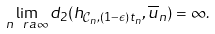<formula> <loc_0><loc_0><loc_500><loc_500>\lim _ { n \ r a \infty } d _ { 2 } ( h _ { \mathcal { C } _ { n } , ( 1 - \epsilon ) t _ { n } } , \overline { u } _ { n } ) = \infty .</formula> 